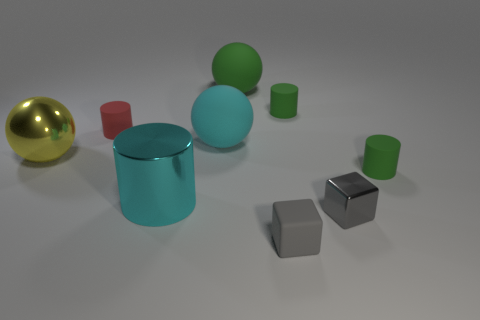Subtract all big green rubber spheres. How many spheres are left? 2 Subtract all cyan cylinders. How many cylinders are left? 3 Subtract all purple cylinders. Subtract all red balls. How many cylinders are left? 4 Subtract all spheres. How many objects are left? 6 Add 8 small gray metal objects. How many small gray metal objects are left? 9 Add 2 large gray balls. How many large gray balls exist? 2 Subtract 1 green balls. How many objects are left? 8 Subtract all small yellow metal cylinders. Subtract all green spheres. How many objects are left? 8 